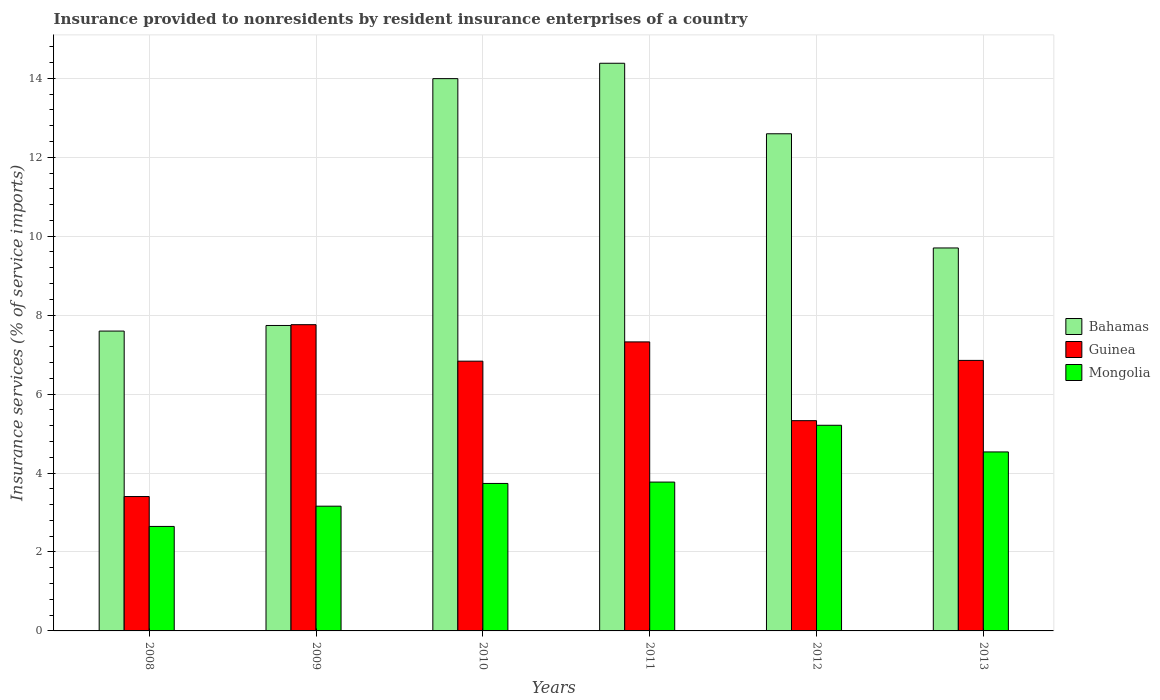How many different coloured bars are there?
Offer a terse response. 3. What is the insurance provided to nonresidents in Mongolia in 2009?
Give a very brief answer. 3.16. Across all years, what is the maximum insurance provided to nonresidents in Bahamas?
Provide a short and direct response. 14.38. Across all years, what is the minimum insurance provided to nonresidents in Mongolia?
Offer a terse response. 2.65. In which year was the insurance provided to nonresidents in Mongolia minimum?
Provide a short and direct response. 2008. What is the total insurance provided to nonresidents in Bahamas in the graph?
Provide a short and direct response. 66. What is the difference between the insurance provided to nonresidents in Bahamas in 2011 and that in 2013?
Ensure brevity in your answer.  4.68. What is the difference between the insurance provided to nonresidents in Guinea in 2008 and the insurance provided to nonresidents in Mongolia in 2013?
Your response must be concise. -1.13. What is the average insurance provided to nonresidents in Mongolia per year?
Offer a terse response. 3.84. In the year 2013, what is the difference between the insurance provided to nonresidents in Mongolia and insurance provided to nonresidents in Bahamas?
Offer a very short reply. -5.17. What is the ratio of the insurance provided to nonresidents in Bahamas in 2009 to that in 2012?
Ensure brevity in your answer.  0.61. Is the insurance provided to nonresidents in Guinea in 2010 less than that in 2012?
Provide a succinct answer. No. Is the difference between the insurance provided to nonresidents in Mongolia in 2010 and 2013 greater than the difference between the insurance provided to nonresidents in Bahamas in 2010 and 2013?
Your response must be concise. No. What is the difference between the highest and the second highest insurance provided to nonresidents in Mongolia?
Provide a short and direct response. 0.68. What is the difference between the highest and the lowest insurance provided to nonresidents in Bahamas?
Your response must be concise. 6.78. Is the sum of the insurance provided to nonresidents in Bahamas in 2009 and 2013 greater than the maximum insurance provided to nonresidents in Guinea across all years?
Provide a short and direct response. Yes. What does the 1st bar from the left in 2009 represents?
Offer a terse response. Bahamas. What does the 1st bar from the right in 2013 represents?
Offer a very short reply. Mongolia. What is the difference between two consecutive major ticks on the Y-axis?
Ensure brevity in your answer.  2. Does the graph contain any zero values?
Ensure brevity in your answer.  No. Where does the legend appear in the graph?
Your answer should be compact. Center right. How are the legend labels stacked?
Offer a very short reply. Vertical. What is the title of the graph?
Your answer should be compact. Insurance provided to nonresidents by resident insurance enterprises of a country. What is the label or title of the X-axis?
Your response must be concise. Years. What is the label or title of the Y-axis?
Offer a very short reply. Insurance services (% of service imports). What is the Insurance services (% of service imports) of Bahamas in 2008?
Ensure brevity in your answer.  7.6. What is the Insurance services (% of service imports) of Guinea in 2008?
Keep it short and to the point. 3.4. What is the Insurance services (% of service imports) in Mongolia in 2008?
Your answer should be very brief. 2.65. What is the Insurance services (% of service imports) of Bahamas in 2009?
Offer a terse response. 7.74. What is the Insurance services (% of service imports) in Guinea in 2009?
Give a very brief answer. 7.76. What is the Insurance services (% of service imports) in Mongolia in 2009?
Offer a very short reply. 3.16. What is the Insurance services (% of service imports) in Bahamas in 2010?
Provide a succinct answer. 13.99. What is the Insurance services (% of service imports) in Guinea in 2010?
Ensure brevity in your answer.  6.83. What is the Insurance services (% of service imports) in Mongolia in 2010?
Your response must be concise. 3.74. What is the Insurance services (% of service imports) in Bahamas in 2011?
Your answer should be very brief. 14.38. What is the Insurance services (% of service imports) of Guinea in 2011?
Keep it short and to the point. 7.32. What is the Insurance services (% of service imports) of Mongolia in 2011?
Keep it short and to the point. 3.77. What is the Insurance services (% of service imports) in Bahamas in 2012?
Your response must be concise. 12.59. What is the Insurance services (% of service imports) in Guinea in 2012?
Make the answer very short. 5.33. What is the Insurance services (% of service imports) of Mongolia in 2012?
Provide a short and direct response. 5.21. What is the Insurance services (% of service imports) of Bahamas in 2013?
Give a very brief answer. 9.7. What is the Insurance services (% of service imports) in Guinea in 2013?
Ensure brevity in your answer.  6.85. What is the Insurance services (% of service imports) of Mongolia in 2013?
Your answer should be compact. 4.53. Across all years, what is the maximum Insurance services (% of service imports) of Bahamas?
Offer a very short reply. 14.38. Across all years, what is the maximum Insurance services (% of service imports) in Guinea?
Offer a very short reply. 7.76. Across all years, what is the maximum Insurance services (% of service imports) of Mongolia?
Your response must be concise. 5.21. Across all years, what is the minimum Insurance services (% of service imports) in Bahamas?
Offer a terse response. 7.6. Across all years, what is the minimum Insurance services (% of service imports) of Guinea?
Offer a terse response. 3.4. Across all years, what is the minimum Insurance services (% of service imports) of Mongolia?
Your response must be concise. 2.65. What is the total Insurance services (% of service imports) of Bahamas in the graph?
Provide a short and direct response. 66. What is the total Insurance services (% of service imports) in Guinea in the graph?
Keep it short and to the point. 37.5. What is the total Insurance services (% of service imports) of Mongolia in the graph?
Provide a short and direct response. 23.06. What is the difference between the Insurance services (% of service imports) in Bahamas in 2008 and that in 2009?
Offer a very short reply. -0.14. What is the difference between the Insurance services (% of service imports) of Guinea in 2008 and that in 2009?
Make the answer very short. -4.35. What is the difference between the Insurance services (% of service imports) in Mongolia in 2008 and that in 2009?
Your answer should be compact. -0.51. What is the difference between the Insurance services (% of service imports) of Bahamas in 2008 and that in 2010?
Ensure brevity in your answer.  -6.39. What is the difference between the Insurance services (% of service imports) of Guinea in 2008 and that in 2010?
Offer a terse response. -3.43. What is the difference between the Insurance services (% of service imports) of Mongolia in 2008 and that in 2010?
Provide a short and direct response. -1.09. What is the difference between the Insurance services (% of service imports) in Bahamas in 2008 and that in 2011?
Provide a succinct answer. -6.78. What is the difference between the Insurance services (% of service imports) in Guinea in 2008 and that in 2011?
Keep it short and to the point. -3.92. What is the difference between the Insurance services (% of service imports) of Mongolia in 2008 and that in 2011?
Your answer should be very brief. -1.12. What is the difference between the Insurance services (% of service imports) in Bahamas in 2008 and that in 2012?
Make the answer very short. -5. What is the difference between the Insurance services (% of service imports) in Guinea in 2008 and that in 2012?
Provide a succinct answer. -1.92. What is the difference between the Insurance services (% of service imports) in Mongolia in 2008 and that in 2012?
Your response must be concise. -2.56. What is the difference between the Insurance services (% of service imports) in Bahamas in 2008 and that in 2013?
Make the answer very short. -2.11. What is the difference between the Insurance services (% of service imports) in Guinea in 2008 and that in 2013?
Your answer should be very brief. -3.45. What is the difference between the Insurance services (% of service imports) in Mongolia in 2008 and that in 2013?
Your answer should be very brief. -1.89. What is the difference between the Insurance services (% of service imports) in Bahamas in 2009 and that in 2010?
Give a very brief answer. -6.25. What is the difference between the Insurance services (% of service imports) in Guinea in 2009 and that in 2010?
Your response must be concise. 0.92. What is the difference between the Insurance services (% of service imports) of Mongolia in 2009 and that in 2010?
Keep it short and to the point. -0.58. What is the difference between the Insurance services (% of service imports) in Bahamas in 2009 and that in 2011?
Your response must be concise. -6.64. What is the difference between the Insurance services (% of service imports) of Guinea in 2009 and that in 2011?
Provide a succinct answer. 0.44. What is the difference between the Insurance services (% of service imports) of Mongolia in 2009 and that in 2011?
Your response must be concise. -0.61. What is the difference between the Insurance services (% of service imports) in Bahamas in 2009 and that in 2012?
Offer a terse response. -4.86. What is the difference between the Insurance services (% of service imports) in Guinea in 2009 and that in 2012?
Provide a short and direct response. 2.43. What is the difference between the Insurance services (% of service imports) of Mongolia in 2009 and that in 2012?
Ensure brevity in your answer.  -2.05. What is the difference between the Insurance services (% of service imports) in Bahamas in 2009 and that in 2013?
Your answer should be compact. -1.96. What is the difference between the Insurance services (% of service imports) in Guinea in 2009 and that in 2013?
Your response must be concise. 0.91. What is the difference between the Insurance services (% of service imports) of Mongolia in 2009 and that in 2013?
Offer a very short reply. -1.37. What is the difference between the Insurance services (% of service imports) in Bahamas in 2010 and that in 2011?
Provide a succinct answer. -0.39. What is the difference between the Insurance services (% of service imports) of Guinea in 2010 and that in 2011?
Keep it short and to the point. -0.49. What is the difference between the Insurance services (% of service imports) of Mongolia in 2010 and that in 2011?
Keep it short and to the point. -0.03. What is the difference between the Insurance services (% of service imports) in Bahamas in 2010 and that in 2012?
Offer a very short reply. 1.4. What is the difference between the Insurance services (% of service imports) in Guinea in 2010 and that in 2012?
Provide a short and direct response. 1.51. What is the difference between the Insurance services (% of service imports) of Mongolia in 2010 and that in 2012?
Ensure brevity in your answer.  -1.47. What is the difference between the Insurance services (% of service imports) in Bahamas in 2010 and that in 2013?
Your answer should be compact. 4.29. What is the difference between the Insurance services (% of service imports) of Guinea in 2010 and that in 2013?
Keep it short and to the point. -0.02. What is the difference between the Insurance services (% of service imports) in Mongolia in 2010 and that in 2013?
Your answer should be compact. -0.8. What is the difference between the Insurance services (% of service imports) in Bahamas in 2011 and that in 2012?
Your response must be concise. 1.79. What is the difference between the Insurance services (% of service imports) in Guinea in 2011 and that in 2012?
Your answer should be compact. 2. What is the difference between the Insurance services (% of service imports) in Mongolia in 2011 and that in 2012?
Your answer should be very brief. -1.44. What is the difference between the Insurance services (% of service imports) of Bahamas in 2011 and that in 2013?
Ensure brevity in your answer.  4.68. What is the difference between the Insurance services (% of service imports) in Guinea in 2011 and that in 2013?
Your response must be concise. 0.47. What is the difference between the Insurance services (% of service imports) of Mongolia in 2011 and that in 2013?
Your answer should be compact. -0.76. What is the difference between the Insurance services (% of service imports) of Bahamas in 2012 and that in 2013?
Your answer should be compact. 2.89. What is the difference between the Insurance services (% of service imports) of Guinea in 2012 and that in 2013?
Your answer should be compact. -1.53. What is the difference between the Insurance services (% of service imports) in Mongolia in 2012 and that in 2013?
Ensure brevity in your answer.  0.68. What is the difference between the Insurance services (% of service imports) in Bahamas in 2008 and the Insurance services (% of service imports) in Guinea in 2009?
Your answer should be very brief. -0.16. What is the difference between the Insurance services (% of service imports) of Bahamas in 2008 and the Insurance services (% of service imports) of Mongolia in 2009?
Keep it short and to the point. 4.44. What is the difference between the Insurance services (% of service imports) in Guinea in 2008 and the Insurance services (% of service imports) in Mongolia in 2009?
Give a very brief answer. 0.24. What is the difference between the Insurance services (% of service imports) in Bahamas in 2008 and the Insurance services (% of service imports) in Guinea in 2010?
Your answer should be very brief. 0.76. What is the difference between the Insurance services (% of service imports) of Bahamas in 2008 and the Insurance services (% of service imports) of Mongolia in 2010?
Provide a succinct answer. 3.86. What is the difference between the Insurance services (% of service imports) in Guinea in 2008 and the Insurance services (% of service imports) in Mongolia in 2010?
Provide a succinct answer. -0.33. What is the difference between the Insurance services (% of service imports) of Bahamas in 2008 and the Insurance services (% of service imports) of Guinea in 2011?
Give a very brief answer. 0.27. What is the difference between the Insurance services (% of service imports) in Bahamas in 2008 and the Insurance services (% of service imports) in Mongolia in 2011?
Offer a very short reply. 3.83. What is the difference between the Insurance services (% of service imports) of Guinea in 2008 and the Insurance services (% of service imports) of Mongolia in 2011?
Make the answer very short. -0.37. What is the difference between the Insurance services (% of service imports) of Bahamas in 2008 and the Insurance services (% of service imports) of Guinea in 2012?
Provide a succinct answer. 2.27. What is the difference between the Insurance services (% of service imports) of Bahamas in 2008 and the Insurance services (% of service imports) of Mongolia in 2012?
Offer a terse response. 2.39. What is the difference between the Insurance services (% of service imports) of Guinea in 2008 and the Insurance services (% of service imports) of Mongolia in 2012?
Give a very brief answer. -1.81. What is the difference between the Insurance services (% of service imports) of Bahamas in 2008 and the Insurance services (% of service imports) of Guinea in 2013?
Your answer should be compact. 0.74. What is the difference between the Insurance services (% of service imports) in Bahamas in 2008 and the Insurance services (% of service imports) in Mongolia in 2013?
Your answer should be compact. 3.06. What is the difference between the Insurance services (% of service imports) in Guinea in 2008 and the Insurance services (% of service imports) in Mongolia in 2013?
Provide a short and direct response. -1.13. What is the difference between the Insurance services (% of service imports) of Bahamas in 2009 and the Insurance services (% of service imports) of Guinea in 2010?
Provide a short and direct response. 0.9. What is the difference between the Insurance services (% of service imports) of Bahamas in 2009 and the Insurance services (% of service imports) of Mongolia in 2010?
Provide a succinct answer. 4. What is the difference between the Insurance services (% of service imports) in Guinea in 2009 and the Insurance services (% of service imports) in Mongolia in 2010?
Your answer should be compact. 4.02. What is the difference between the Insurance services (% of service imports) in Bahamas in 2009 and the Insurance services (% of service imports) in Guinea in 2011?
Ensure brevity in your answer.  0.42. What is the difference between the Insurance services (% of service imports) of Bahamas in 2009 and the Insurance services (% of service imports) of Mongolia in 2011?
Offer a terse response. 3.97. What is the difference between the Insurance services (% of service imports) of Guinea in 2009 and the Insurance services (% of service imports) of Mongolia in 2011?
Ensure brevity in your answer.  3.99. What is the difference between the Insurance services (% of service imports) in Bahamas in 2009 and the Insurance services (% of service imports) in Guinea in 2012?
Ensure brevity in your answer.  2.41. What is the difference between the Insurance services (% of service imports) of Bahamas in 2009 and the Insurance services (% of service imports) of Mongolia in 2012?
Give a very brief answer. 2.53. What is the difference between the Insurance services (% of service imports) in Guinea in 2009 and the Insurance services (% of service imports) in Mongolia in 2012?
Your answer should be very brief. 2.55. What is the difference between the Insurance services (% of service imports) of Bahamas in 2009 and the Insurance services (% of service imports) of Guinea in 2013?
Ensure brevity in your answer.  0.88. What is the difference between the Insurance services (% of service imports) in Bahamas in 2009 and the Insurance services (% of service imports) in Mongolia in 2013?
Offer a very short reply. 3.2. What is the difference between the Insurance services (% of service imports) of Guinea in 2009 and the Insurance services (% of service imports) of Mongolia in 2013?
Make the answer very short. 3.22. What is the difference between the Insurance services (% of service imports) in Bahamas in 2010 and the Insurance services (% of service imports) in Guinea in 2011?
Your answer should be very brief. 6.67. What is the difference between the Insurance services (% of service imports) in Bahamas in 2010 and the Insurance services (% of service imports) in Mongolia in 2011?
Keep it short and to the point. 10.22. What is the difference between the Insurance services (% of service imports) in Guinea in 2010 and the Insurance services (% of service imports) in Mongolia in 2011?
Ensure brevity in your answer.  3.06. What is the difference between the Insurance services (% of service imports) in Bahamas in 2010 and the Insurance services (% of service imports) in Guinea in 2012?
Your response must be concise. 8.66. What is the difference between the Insurance services (% of service imports) in Bahamas in 2010 and the Insurance services (% of service imports) in Mongolia in 2012?
Provide a short and direct response. 8.78. What is the difference between the Insurance services (% of service imports) of Guinea in 2010 and the Insurance services (% of service imports) of Mongolia in 2012?
Offer a very short reply. 1.62. What is the difference between the Insurance services (% of service imports) in Bahamas in 2010 and the Insurance services (% of service imports) in Guinea in 2013?
Offer a very short reply. 7.14. What is the difference between the Insurance services (% of service imports) in Bahamas in 2010 and the Insurance services (% of service imports) in Mongolia in 2013?
Offer a terse response. 9.46. What is the difference between the Insurance services (% of service imports) in Guinea in 2010 and the Insurance services (% of service imports) in Mongolia in 2013?
Provide a succinct answer. 2.3. What is the difference between the Insurance services (% of service imports) of Bahamas in 2011 and the Insurance services (% of service imports) of Guinea in 2012?
Give a very brief answer. 9.05. What is the difference between the Insurance services (% of service imports) of Bahamas in 2011 and the Insurance services (% of service imports) of Mongolia in 2012?
Keep it short and to the point. 9.17. What is the difference between the Insurance services (% of service imports) in Guinea in 2011 and the Insurance services (% of service imports) in Mongolia in 2012?
Offer a very short reply. 2.11. What is the difference between the Insurance services (% of service imports) of Bahamas in 2011 and the Insurance services (% of service imports) of Guinea in 2013?
Give a very brief answer. 7.53. What is the difference between the Insurance services (% of service imports) of Bahamas in 2011 and the Insurance services (% of service imports) of Mongolia in 2013?
Your answer should be compact. 9.85. What is the difference between the Insurance services (% of service imports) of Guinea in 2011 and the Insurance services (% of service imports) of Mongolia in 2013?
Offer a very short reply. 2.79. What is the difference between the Insurance services (% of service imports) of Bahamas in 2012 and the Insurance services (% of service imports) of Guinea in 2013?
Offer a very short reply. 5.74. What is the difference between the Insurance services (% of service imports) of Bahamas in 2012 and the Insurance services (% of service imports) of Mongolia in 2013?
Keep it short and to the point. 8.06. What is the difference between the Insurance services (% of service imports) of Guinea in 2012 and the Insurance services (% of service imports) of Mongolia in 2013?
Offer a terse response. 0.79. What is the average Insurance services (% of service imports) of Bahamas per year?
Your answer should be very brief. 11. What is the average Insurance services (% of service imports) in Guinea per year?
Offer a very short reply. 6.25. What is the average Insurance services (% of service imports) of Mongolia per year?
Your answer should be very brief. 3.84. In the year 2008, what is the difference between the Insurance services (% of service imports) of Bahamas and Insurance services (% of service imports) of Guinea?
Offer a very short reply. 4.19. In the year 2008, what is the difference between the Insurance services (% of service imports) in Bahamas and Insurance services (% of service imports) in Mongolia?
Offer a terse response. 4.95. In the year 2008, what is the difference between the Insurance services (% of service imports) of Guinea and Insurance services (% of service imports) of Mongolia?
Your answer should be compact. 0.76. In the year 2009, what is the difference between the Insurance services (% of service imports) of Bahamas and Insurance services (% of service imports) of Guinea?
Make the answer very short. -0.02. In the year 2009, what is the difference between the Insurance services (% of service imports) in Bahamas and Insurance services (% of service imports) in Mongolia?
Make the answer very short. 4.58. In the year 2009, what is the difference between the Insurance services (% of service imports) in Guinea and Insurance services (% of service imports) in Mongolia?
Keep it short and to the point. 4.6. In the year 2010, what is the difference between the Insurance services (% of service imports) in Bahamas and Insurance services (% of service imports) in Guinea?
Provide a succinct answer. 7.16. In the year 2010, what is the difference between the Insurance services (% of service imports) of Bahamas and Insurance services (% of service imports) of Mongolia?
Provide a succinct answer. 10.26. In the year 2010, what is the difference between the Insurance services (% of service imports) of Guinea and Insurance services (% of service imports) of Mongolia?
Make the answer very short. 3.1. In the year 2011, what is the difference between the Insurance services (% of service imports) in Bahamas and Insurance services (% of service imports) in Guinea?
Provide a succinct answer. 7.06. In the year 2011, what is the difference between the Insurance services (% of service imports) in Bahamas and Insurance services (% of service imports) in Mongolia?
Your response must be concise. 10.61. In the year 2011, what is the difference between the Insurance services (% of service imports) in Guinea and Insurance services (% of service imports) in Mongolia?
Your answer should be compact. 3.55. In the year 2012, what is the difference between the Insurance services (% of service imports) of Bahamas and Insurance services (% of service imports) of Guinea?
Provide a short and direct response. 7.27. In the year 2012, what is the difference between the Insurance services (% of service imports) of Bahamas and Insurance services (% of service imports) of Mongolia?
Make the answer very short. 7.38. In the year 2012, what is the difference between the Insurance services (% of service imports) of Guinea and Insurance services (% of service imports) of Mongolia?
Your answer should be very brief. 0.12. In the year 2013, what is the difference between the Insurance services (% of service imports) in Bahamas and Insurance services (% of service imports) in Guinea?
Your answer should be very brief. 2.85. In the year 2013, what is the difference between the Insurance services (% of service imports) in Bahamas and Insurance services (% of service imports) in Mongolia?
Keep it short and to the point. 5.17. In the year 2013, what is the difference between the Insurance services (% of service imports) of Guinea and Insurance services (% of service imports) of Mongolia?
Provide a short and direct response. 2.32. What is the ratio of the Insurance services (% of service imports) of Bahamas in 2008 to that in 2009?
Provide a short and direct response. 0.98. What is the ratio of the Insurance services (% of service imports) of Guinea in 2008 to that in 2009?
Ensure brevity in your answer.  0.44. What is the ratio of the Insurance services (% of service imports) of Mongolia in 2008 to that in 2009?
Provide a short and direct response. 0.84. What is the ratio of the Insurance services (% of service imports) of Bahamas in 2008 to that in 2010?
Ensure brevity in your answer.  0.54. What is the ratio of the Insurance services (% of service imports) of Guinea in 2008 to that in 2010?
Keep it short and to the point. 0.5. What is the ratio of the Insurance services (% of service imports) of Mongolia in 2008 to that in 2010?
Your answer should be compact. 0.71. What is the ratio of the Insurance services (% of service imports) of Bahamas in 2008 to that in 2011?
Make the answer very short. 0.53. What is the ratio of the Insurance services (% of service imports) in Guinea in 2008 to that in 2011?
Offer a very short reply. 0.47. What is the ratio of the Insurance services (% of service imports) in Mongolia in 2008 to that in 2011?
Ensure brevity in your answer.  0.7. What is the ratio of the Insurance services (% of service imports) in Bahamas in 2008 to that in 2012?
Provide a short and direct response. 0.6. What is the ratio of the Insurance services (% of service imports) in Guinea in 2008 to that in 2012?
Ensure brevity in your answer.  0.64. What is the ratio of the Insurance services (% of service imports) of Mongolia in 2008 to that in 2012?
Your answer should be very brief. 0.51. What is the ratio of the Insurance services (% of service imports) in Bahamas in 2008 to that in 2013?
Your answer should be compact. 0.78. What is the ratio of the Insurance services (% of service imports) of Guinea in 2008 to that in 2013?
Your answer should be compact. 0.5. What is the ratio of the Insurance services (% of service imports) in Mongolia in 2008 to that in 2013?
Ensure brevity in your answer.  0.58. What is the ratio of the Insurance services (% of service imports) in Bahamas in 2009 to that in 2010?
Your answer should be very brief. 0.55. What is the ratio of the Insurance services (% of service imports) of Guinea in 2009 to that in 2010?
Your answer should be compact. 1.14. What is the ratio of the Insurance services (% of service imports) in Mongolia in 2009 to that in 2010?
Your answer should be compact. 0.85. What is the ratio of the Insurance services (% of service imports) in Bahamas in 2009 to that in 2011?
Keep it short and to the point. 0.54. What is the ratio of the Insurance services (% of service imports) of Guinea in 2009 to that in 2011?
Make the answer very short. 1.06. What is the ratio of the Insurance services (% of service imports) in Mongolia in 2009 to that in 2011?
Give a very brief answer. 0.84. What is the ratio of the Insurance services (% of service imports) of Bahamas in 2009 to that in 2012?
Your answer should be compact. 0.61. What is the ratio of the Insurance services (% of service imports) in Guinea in 2009 to that in 2012?
Provide a succinct answer. 1.46. What is the ratio of the Insurance services (% of service imports) in Mongolia in 2009 to that in 2012?
Give a very brief answer. 0.61. What is the ratio of the Insurance services (% of service imports) in Bahamas in 2009 to that in 2013?
Provide a short and direct response. 0.8. What is the ratio of the Insurance services (% of service imports) of Guinea in 2009 to that in 2013?
Keep it short and to the point. 1.13. What is the ratio of the Insurance services (% of service imports) of Mongolia in 2009 to that in 2013?
Your answer should be compact. 0.7. What is the ratio of the Insurance services (% of service imports) of Bahamas in 2010 to that in 2011?
Make the answer very short. 0.97. What is the ratio of the Insurance services (% of service imports) in Guinea in 2010 to that in 2011?
Offer a terse response. 0.93. What is the ratio of the Insurance services (% of service imports) of Mongolia in 2010 to that in 2011?
Provide a succinct answer. 0.99. What is the ratio of the Insurance services (% of service imports) in Bahamas in 2010 to that in 2012?
Your answer should be very brief. 1.11. What is the ratio of the Insurance services (% of service imports) in Guinea in 2010 to that in 2012?
Make the answer very short. 1.28. What is the ratio of the Insurance services (% of service imports) of Mongolia in 2010 to that in 2012?
Offer a terse response. 0.72. What is the ratio of the Insurance services (% of service imports) in Bahamas in 2010 to that in 2013?
Offer a very short reply. 1.44. What is the ratio of the Insurance services (% of service imports) of Guinea in 2010 to that in 2013?
Your response must be concise. 1. What is the ratio of the Insurance services (% of service imports) in Mongolia in 2010 to that in 2013?
Offer a very short reply. 0.82. What is the ratio of the Insurance services (% of service imports) of Bahamas in 2011 to that in 2012?
Offer a terse response. 1.14. What is the ratio of the Insurance services (% of service imports) of Guinea in 2011 to that in 2012?
Your answer should be compact. 1.37. What is the ratio of the Insurance services (% of service imports) of Mongolia in 2011 to that in 2012?
Your answer should be compact. 0.72. What is the ratio of the Insurance services (% of service imports) of Bahamas in 2011 to that in 2013?
Your answer should be very brief. 1.48. What is the ratio of the Insurance services (% of service imports) in Guinea in 2011 to that in 2013?
Provide a succinct answer. 1.07. What is the ratio of the Insurance services (% of service imports) of Mongolia in 2011 to that in 2013?
Offer a very short reply. 0.83. What is the ratio of the Insurance services (% of service imports) in Bahamas in 2012 to that in 2013?
Ensure brevity in your answer.  1.3. What is the ratio of the Insurance services (% of service imports) in Guinea in 2012 to that in 2013?
Make the answer very short. 0.78. What is the ratio of the Insurance services (% of service imports) in Mongolia in 2012 to that in 2013?
Your answer should be very brief. 1.15. What is the difference between the highest and the second highest Insurance services (% of service imports) in Bahamas?
Provide a succinct answer. 0.39. What is the difference between the highest and the second highest Insurance services (% of service imports) in Guinea?
Offer a very short reply. 0.44. What is the difference between the highest and the second highest Insurance services (% of service imports) of Mongolia?
Your response must be concise. 0.68. What is the difference between the highest and the lowest Insurance services (% of service imports) of Bahamas?
Your response must be concise. 6.78. What is the difference between the highest and the lowest Insurance services (% of service imports) in Guinea?
Ensure brevity in your answer.  4.35. What is the difference between the highest and the lowest Insurance services (% of service imports) in Mongolia?
Ensure brevity in your answer.  2.56. 